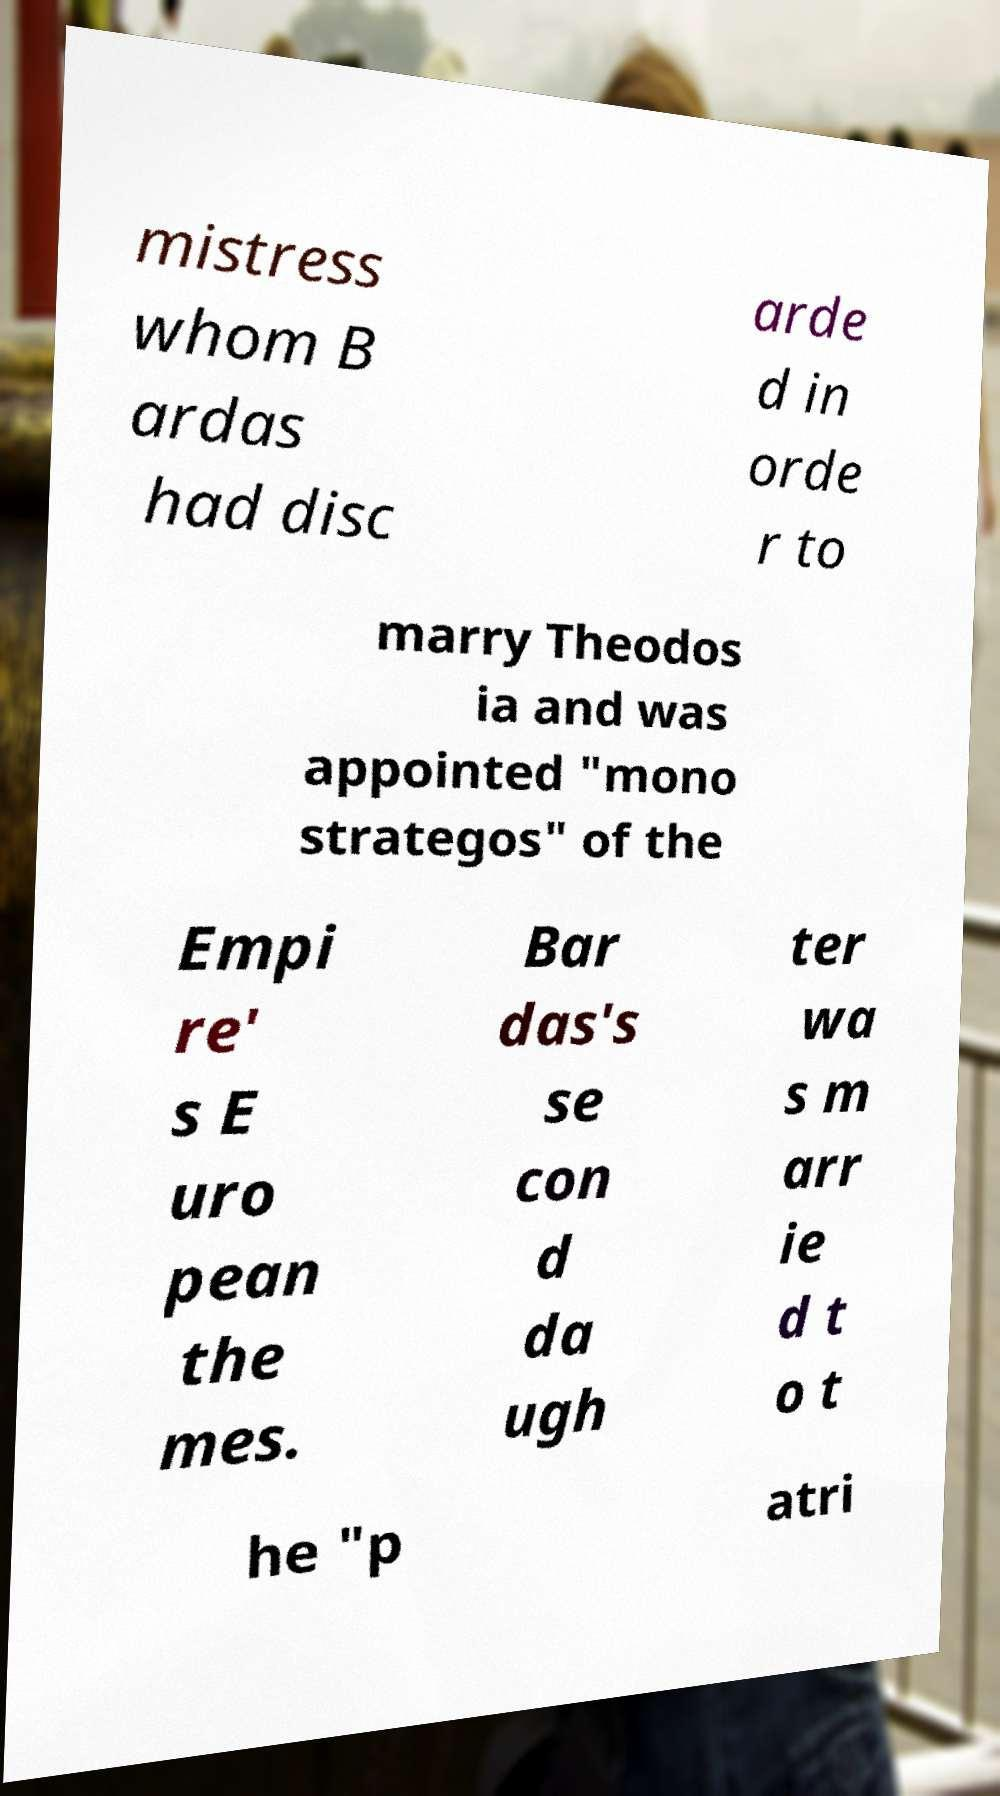Could you assist in decoding the text presented in this image and type it out clearly? mistress whom B ardas had disc arde d in orde r to marry Theodos ia and was appointed "mono strategos" of the Empi re' s E uro pean the mes. Bar das's se con d da ugh ter wa s m arr ie d t o t he "p atri 